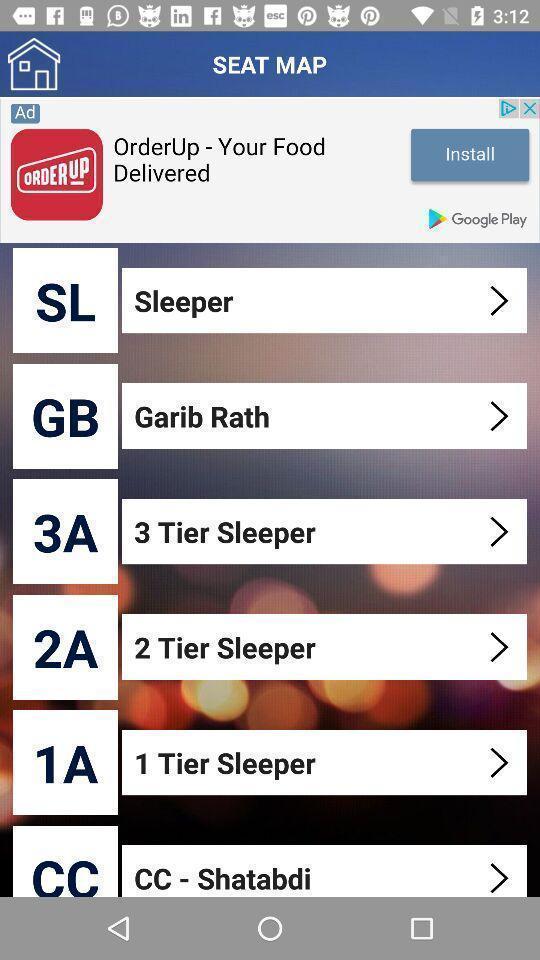Please provide a description for this image. Types of seats in train app. 